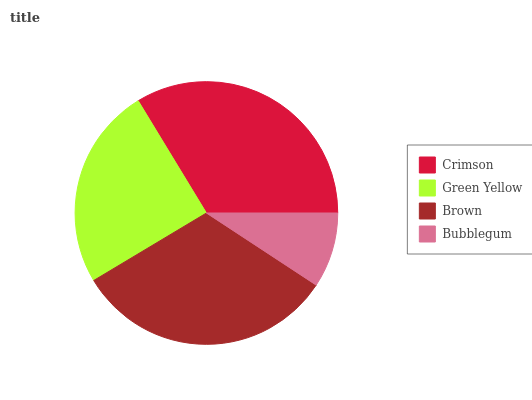Is Bubblegum the minimum?
Answer yes or no. Yes. Is Crimson the maximum?
Answer yes or no. Yes. Is Green Yellow the minimum?
Answer yes or no. No. Is Green Yellow the maximum?
Answer yes or no. No. Is Crimson greater than Green Yellow?
Answer yes or no. Yes. Is Green Yellow less than Crimson?
Answer yes or no. Yes. Is Green Yellow greater than Crimson?
Answer yes or no. No. Is Crimson less than Green Yellow?
Answer yes or no. No. Is Brown the high median?
Answer yes or no. Yes. Is Green Yellow the low median?
Answer yes or no. Yes. Is Green Yellow the high median?
Answer yes or no. No. Is Brown the low median?
Answer yes or no. No. 